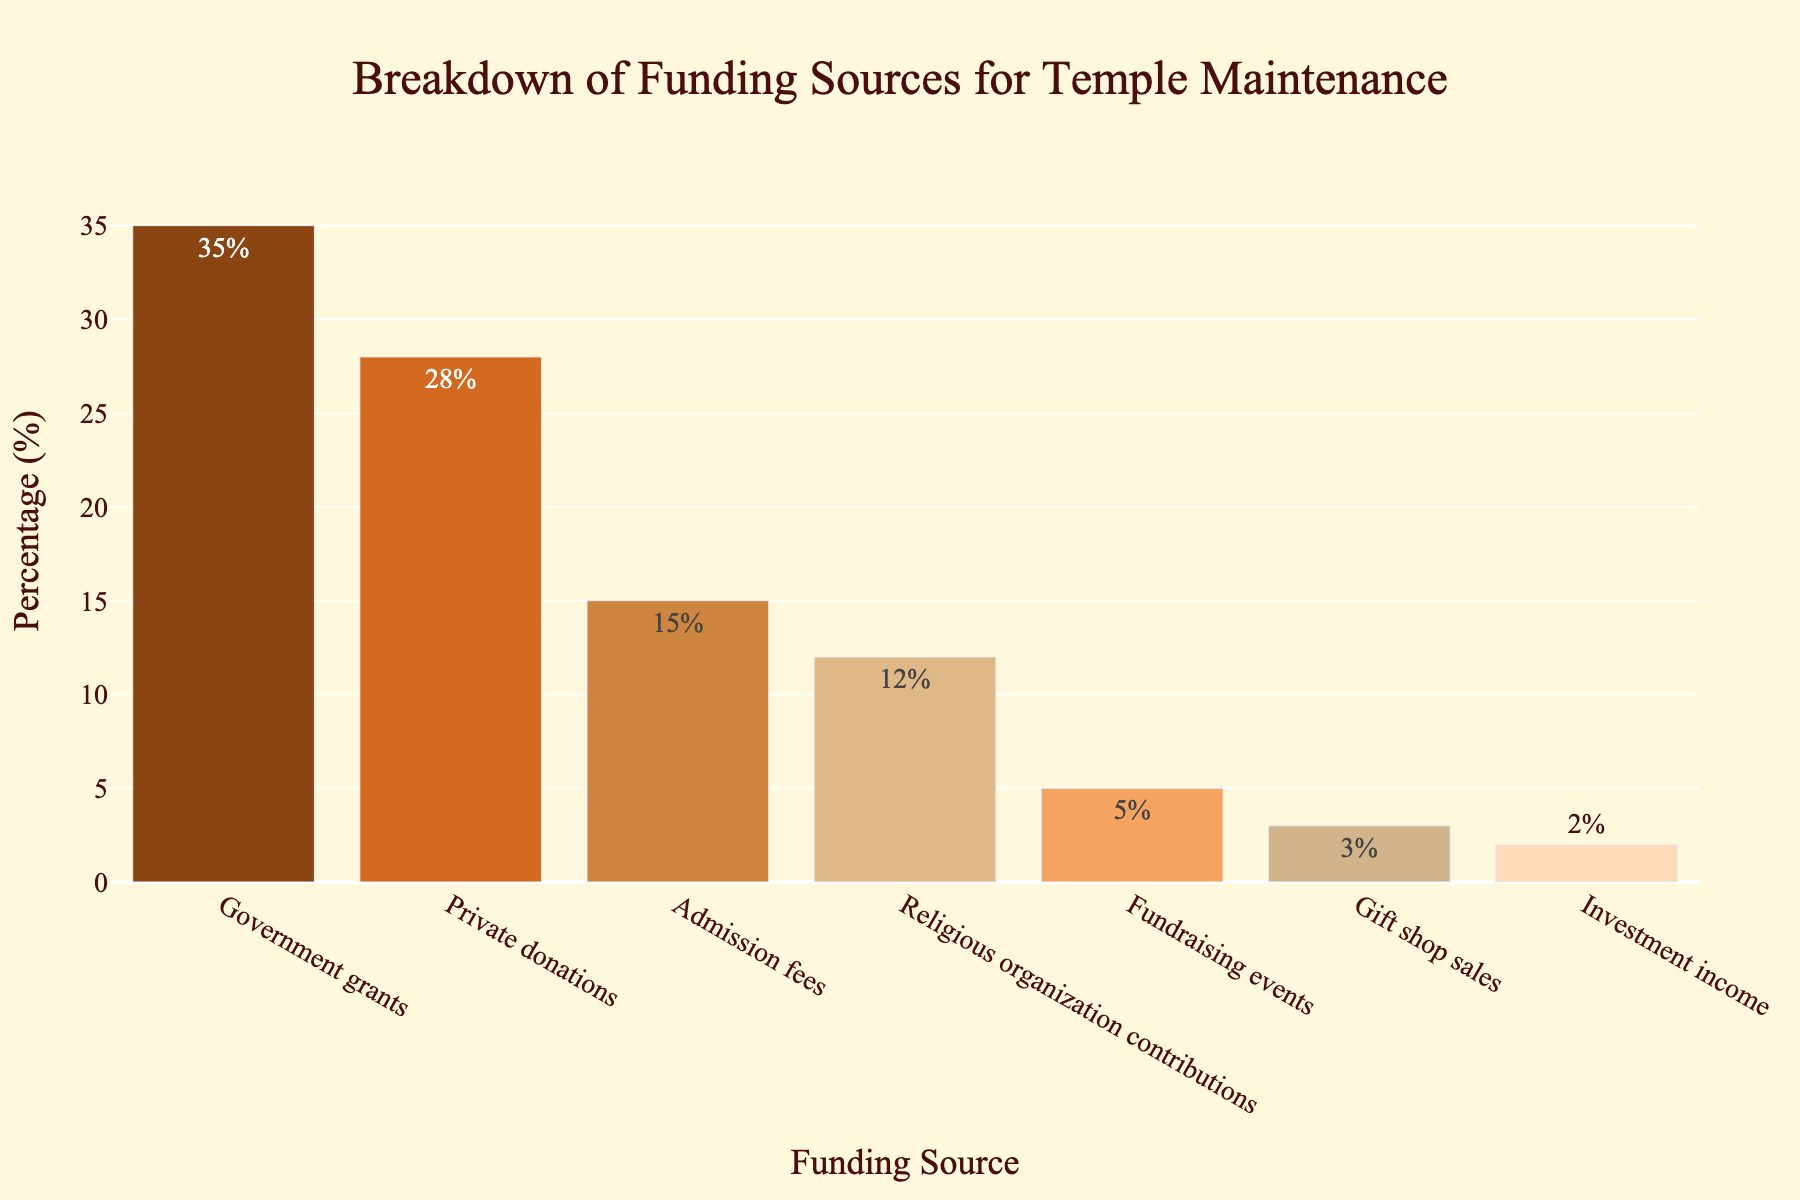Which funding source contributes the highest percentage? The tallest bar in the chart represents the highest percentage. By observing, "Government grants" is the tallest at 35%.
Answer: Government grants Which funding source contributes the lowest percentage? The shortest bar represents the lowest percentage. "Investment income" is the shortest at 2%.
Answer: Investment income What is the combined percentage of Private donations and Admission fees? Add the percentages of "Private donations" and "Admission fees" (28% + 15%).
Answer: 43% Is the percentage of Government grants greater than the combined percentage of Fundraising events and Gift shop sales? Government grants contribute 35%. Adding Fundraising events (5%) and Gift shop sales (3%) results in 8%. Since 35% is greater than 8%, the answer is yes.
Answer: Yes Which funding source has a percentage closest to 20%? By examining the bars' heights, "Admission fees" with 15% is closest to 20%.
Answer: Admission fees How does the sum of percentages for Religious organization contributions and Gift shop sales compare to Private donations? Adding "Religious organization contributions" (12%) and "Gift shop sales" (3%) gives 15%. "Private donations" is 28%. Since 15% is less than 28%, the sum is less.
Answer: Less How many funding sources contribute more than 10% each? Count the bars exceeding the 10% height: "Government grants", "Private donations", "Admission fees", and "Religious organization contributions" - 4 sources.
Answer: 4 What is the difference between the percentages of Government grants and Religious organization contributions? Subtract "Religious organization contributions" (12%) from "Government grants" (35%). (35% - 12% = 23%).
Answer: 23% Are Admission fees higher in percentage than Fundraising events, Gift shop sales, and Investment income combined? Adding "Fundraising events" (5%), "Gift shop sales" (3%), and "Investment income" (2%) gives 10%. Admission fees are 15%, which is higher.
Answer: Yes How does the percentage of Private donations compare to the sum of Fundraising events, Gift shop sales, and Investment income? Adding "Fundraising events" (5%), "Gift shop sales" (3%), and "Investment income" (2%) results in 10%. "Private donations" are 28%, which is greater.
Answer: Greater 